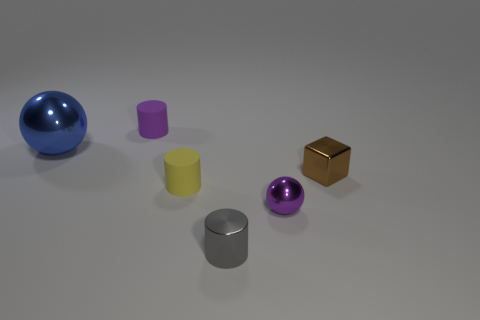Are there any other things that are the same shape as the brown thing?
Offer a terse response. No. Do the big blue object and the purple object in front of the large blue metal ball have the same shape?
Provide a succinct answer. Yes. What is the material of the tiny thing on the right side of the shiny ball that is right of the big blue metal thing?
Give a very brief answer. Metal. What color is the block?
Offer a terse response. Brown. There is a shiny sphere to the right of the gray shiny thing; does it have the same color as the tiny matte object behind the brown thing?
Offer a very short reply. Yes. What size is the other metallic thing that is the same shape as the purple metal thing?
Provide a short and direct response. Large. Are there any cylinders that have the same color as the tiny metallic sphere?
Offer a terse response. Yes. How many rubber objects are the same color as the small metallic ball?
Your answer should be compact. 1. What number of things are either things that are right of the big thing or tiny objects?
Your answer should be very brief. 5. There is another cylinder that is made of the same material as the yellow cylinder; what is its color?
Offer a very short reply. Purple. 